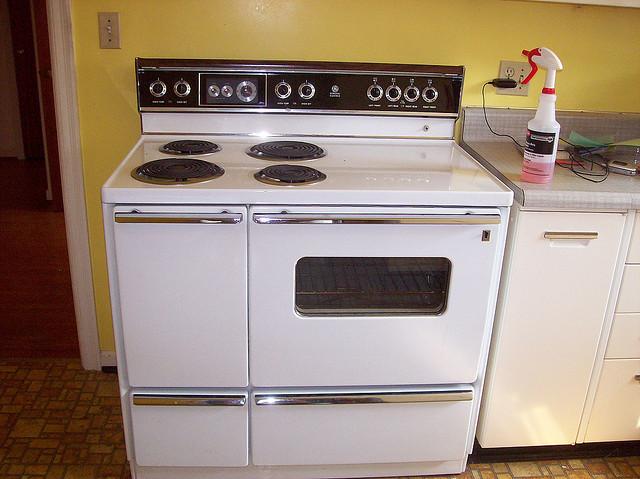Is the range in serviceable condition?
Give a very brief answer. Yes. Is the spray bottle full?
Be succinct. No. What color is the paint in the kitchen?
Be succinct. Yellow. What device is on its charger?
Short answer required. Phone. What color is the oven?
Write a very short answer. White. 